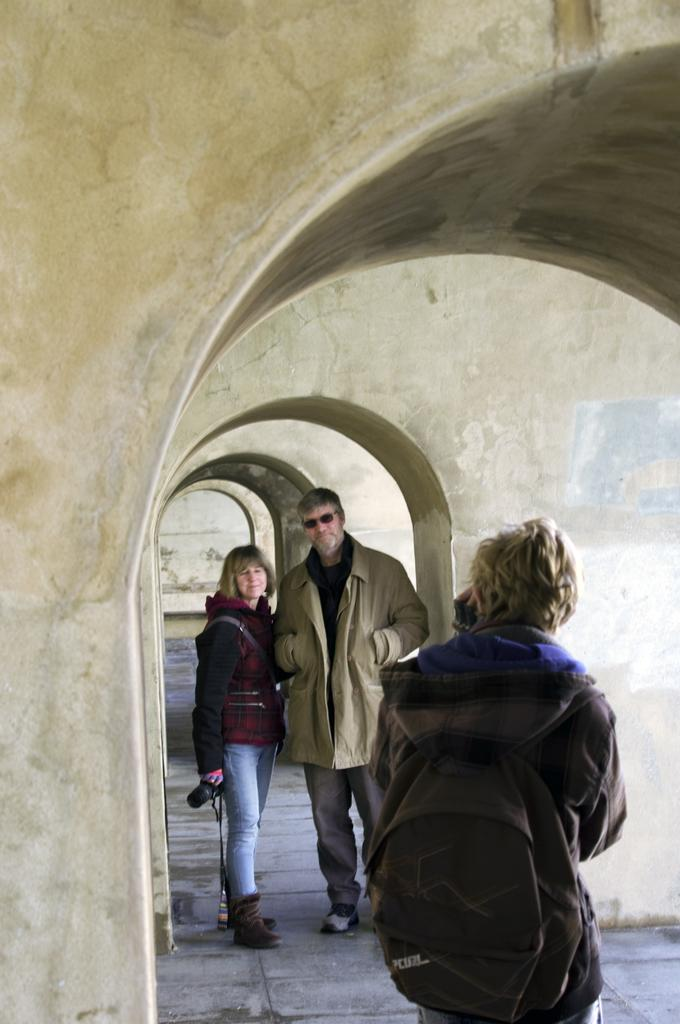How many people are in the foreground of the image? There are three persons in the foreground of the image. What are the persons doing in the image? The persons are on the floor. What type of structure is visible in the image? There is a building with walls visible in the image. Can you determine the time of day the image was taken? The image was likely taken during the day, as there is no indication of darkness or artificial lighting. What type of cap is the hen wearing in the image? There is no hen or cap present in the image. How does the hose connect to the building in the image? There is no hose visible in the image; it only shows three persons on the floor and a building with walls. 